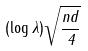<formula> <loc_0><loc_0><loc_500><loc_500>( \log \lambda ) \sqrt { \frac { n d } { 4 } }</formula> 